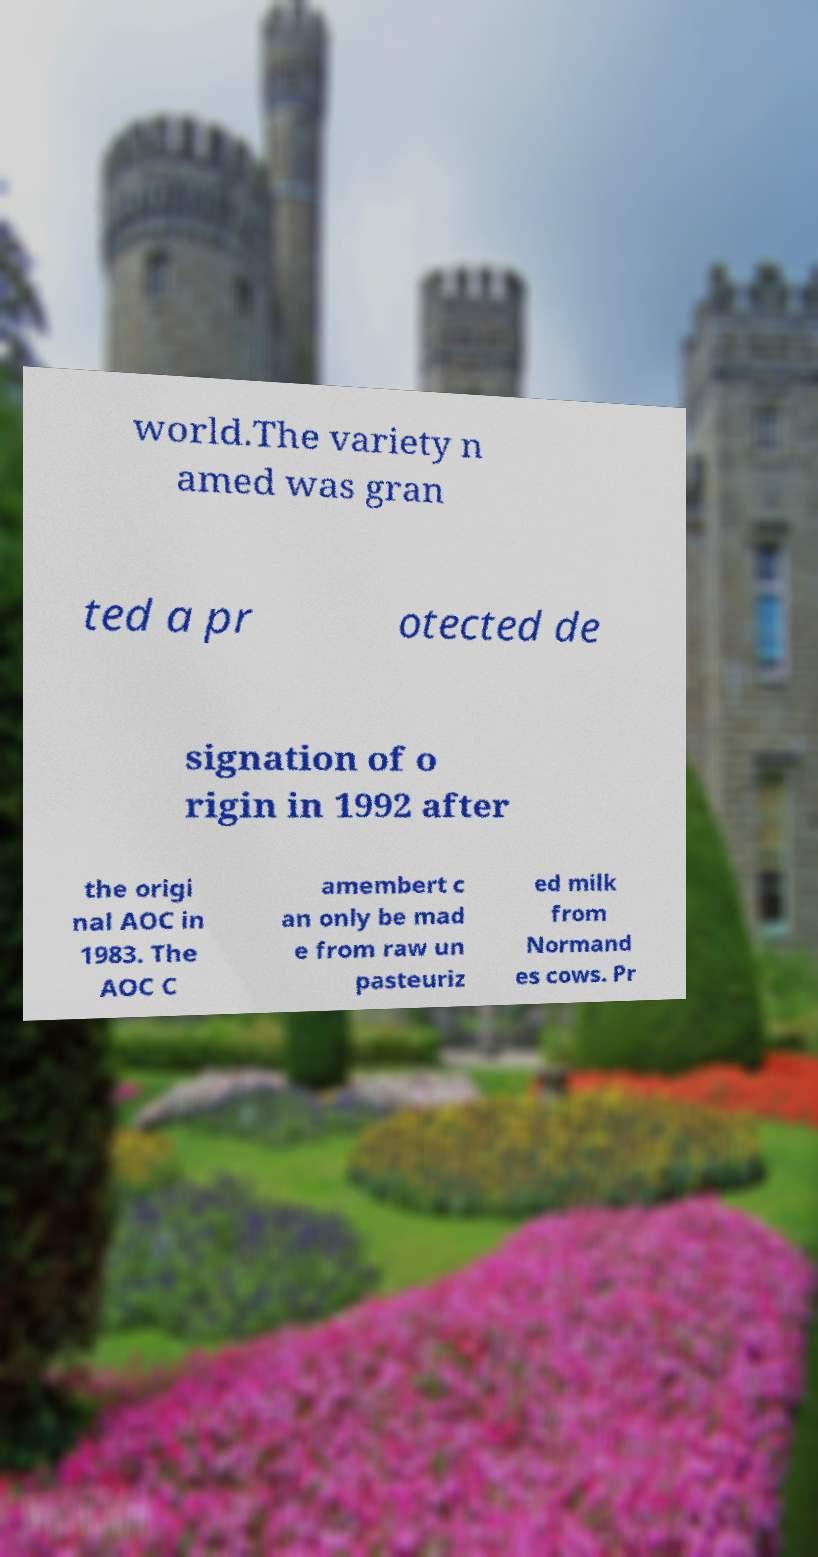Please read and relay the text visible in this image. What does it say? world.The variety n amed was gran ted a pr otected de signation of o rigin in 1992 after the origi nal AOC in 1983. The AOC C amembert c an only be mad e from raw un pasteuriz ed milk from Normand es cows. Pr 